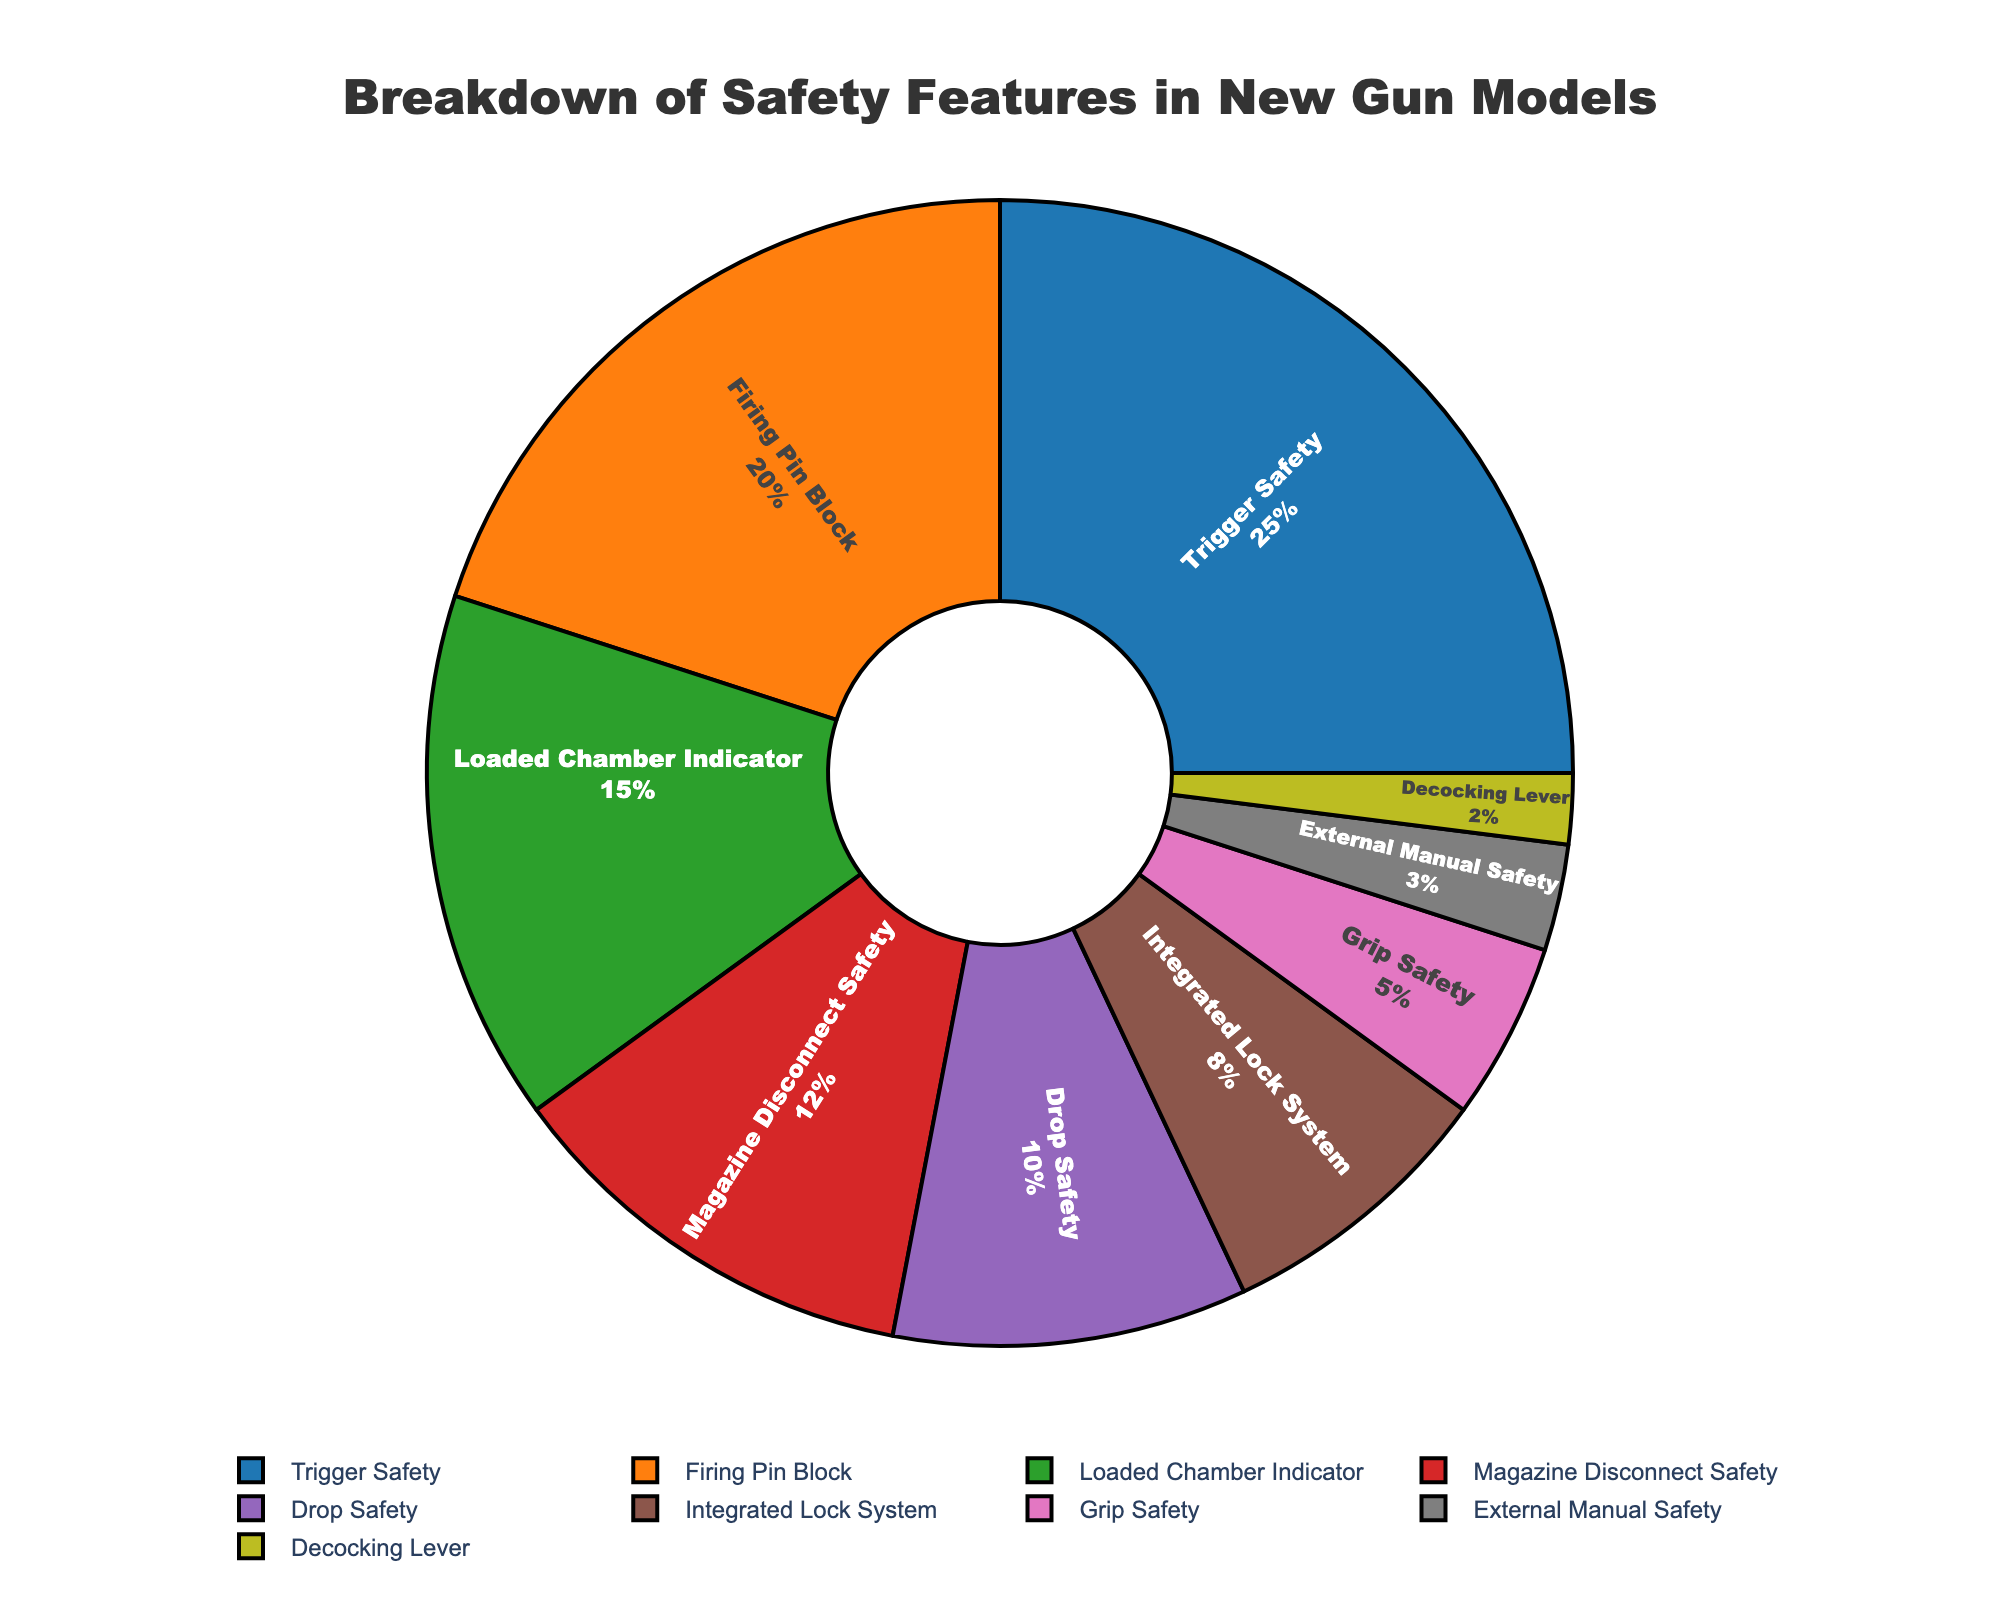what percentage of safety features is attributed to Trigger Safety and Firing Pin Block combined? Add the percentages for Trigger Safety (25%) and Firing Pin Block (20%) to get the combined percentage: 25% + 20% = 45%
Answer: 45% Which safety feature has the highest percentage? By examining the pie chart, the slice for Trigger Safety is the largest, indicating it has the highest percentage at 25%.
Answer: Trigger Safety Which safety feature has the smallest percentage? The smallest slice in the pie chart corresponds to the Decocking Lever, which has a percentage of 2%.
Answer: Decocking Lever What is the difference in percentage between the Loaded Chamber Indicator and the Drop Safety? The percentage for the Loaded Chamber Indicator is 15% and for Drop Safety is 10%. The difference is 15% - 10% = 5%.
Answer: 5% Are there more safety features with a percentage above 10% or below 10%? There are five safety features with percentages above 10% (Trigger Safety, Firing Pin Block, Loaded Chamber Indicator, Magazine Disconnect Safety, Drop Safety) and four safety features with percentages below 10% (Integrated Lock System, Grip Safety, External Manual Safety, Decocking Lever). Therefore, there are more safety features above 10%.
Answer: Above 10% Which safety feature occupies the fourth-largest segment in the pie chart? Based on the size of the segments, the fourth-largest safety feature in the pie chart is Magazine Disconnect Safety at 12%.
Answer: Magazine Disconnect Safety What percentage does the Integrated Lock System cover in the pie chart? The percentage of the Integrated Lock System can be directly read from the pie chart as 8%.
Answer: 8% How many safety features have a percentage of at least 5%? By inspecting the pie chart, seven safety features have percentages of at least 5%: Trigger Safety, Firing Pin Block, Loaded Chamber Indicator, Magazine Disconnect Safety, Drop Safety, Integrated Lock System, and Grip Safety.
Answer: 7 Which safety features together make up just over half of the total percentage? Adding the percentages starting with the highest, Trigger Safety (25%) + Firing Pin Block (20%) = 45%, then add Loaded Chamber Indicator (15%) to get 60%. Thus, Trigger Safety, Firing Pin Block, and Loaded Chamber Indicator together make up just over half of the total percentage.
Answer: Trigger Safety, Firing Pin Block, Loaded Chamber Indicator 